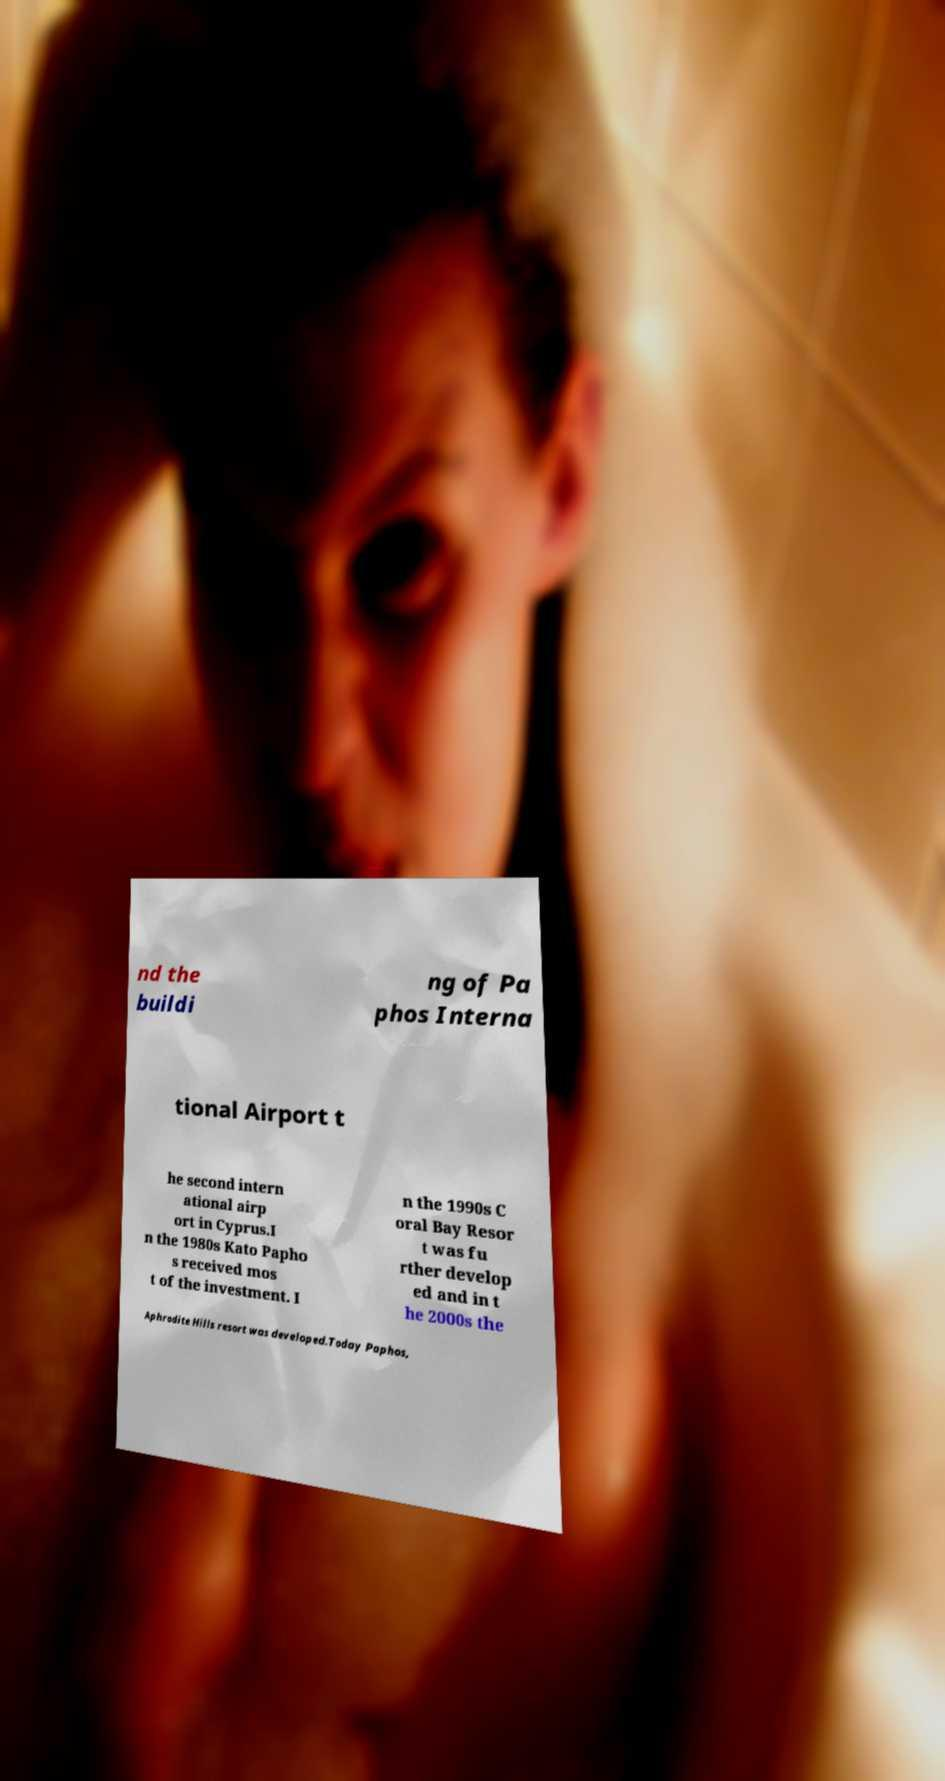There's text embedded in this image that I need extracted. Can you transcribe it verbatim? nd the buildi ng of Pa phos Interna tional Airport t he second intern ational airp ort in Cyprus.I n the 1980s Kato Papho s received mos t of the investment. I n the 1990s C oral Bay Resor t was fu rther develop ed and in t he 2000s the Aphrodite Hills resort was developed.Today Paphos, 